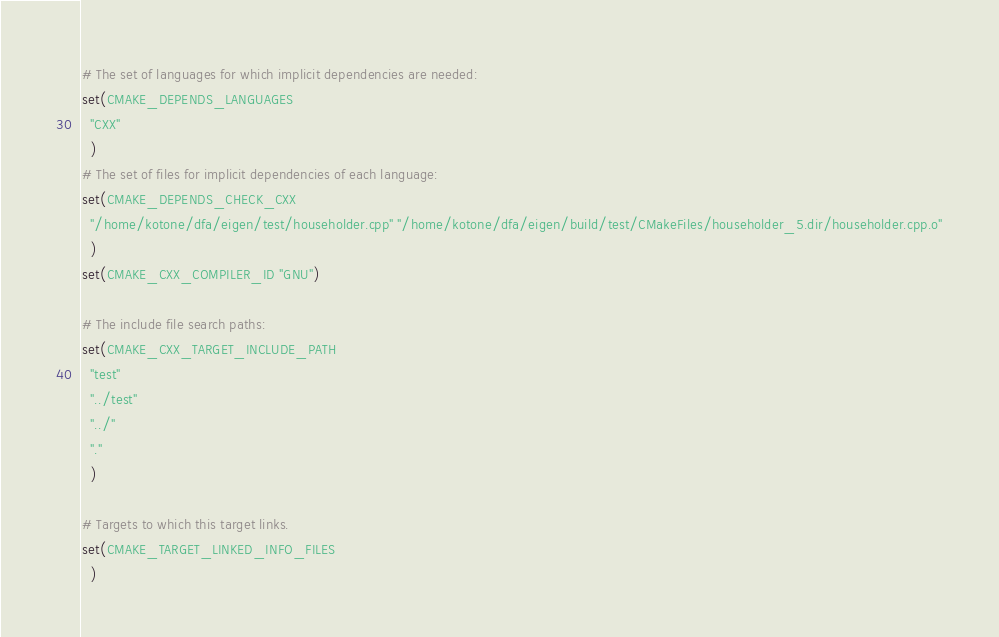Convert code to text. <code><loc_0><loc_0><loc_500><loc_500><_CMake_># The set of languages for which implicit dependencies are needed:
set(CMAKE_DEPENDS_LANGUAGES
  "CXX"
  )
# The set of files for implicit dependencies of each language:
set(CMAKE_DEPENDS_CHECK_CXX
  "/home/kotone/dfa/eigen/test/householder.cpp" "/home/kotone/dfa/eigen/build/test/CMakeFiles/householder_5.dir/householder.cpp.o"
  )
set(CMAKE_CXX_COMPILER_ID "GNU")

# The include file search paths:
set(CMAKE_CXX_TARGET_INCLUDE_PATH
  "test"
  "../test"
  "../"
  "."
  )

# Targets to which this target links.
set(CMAKE_TARGET_LINKED_INFO_FILES
  )
</code> 